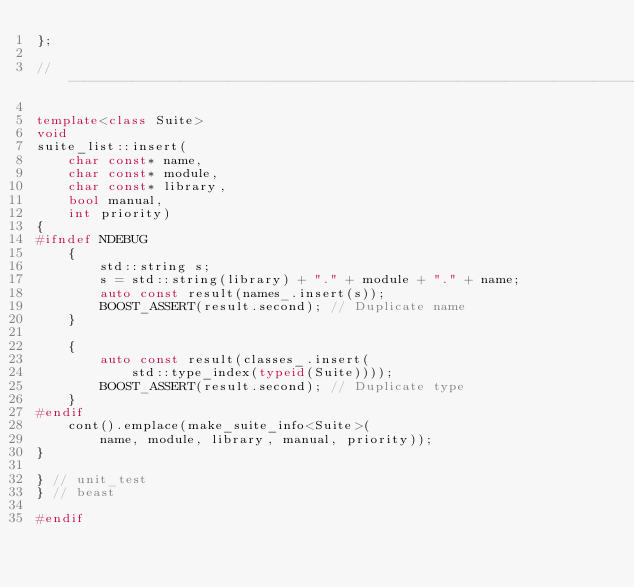<code> <loc_0><loc_0><loc_500><loc_500><_C++_>};

//------------------------------------------------------------------------------

template<class Suite>
void
suite_list::insert(
    char const* name,
    char const* module,
    char const* library,
    bool manual,
    int priority)
{
#ifndef NDEBUG
    {
        std::string s;
        s = std::string(library) + "." + module + "." + name;
        auto const result(names_.insert(s));
        BOOST_ASSERT(result.second); // Duplicate name
    }

    {
        auto const result(classes_.insert(
            std::type_index(typeid(Suite))));
        BOOST_ASSERT(result.second); // Duplicate type
    }
#endif
    cont().emplace(make_suite_info<Suite>(
        name, module, library, manual, priority));
}

} // unit_test
} // beast

#endif
</code> 